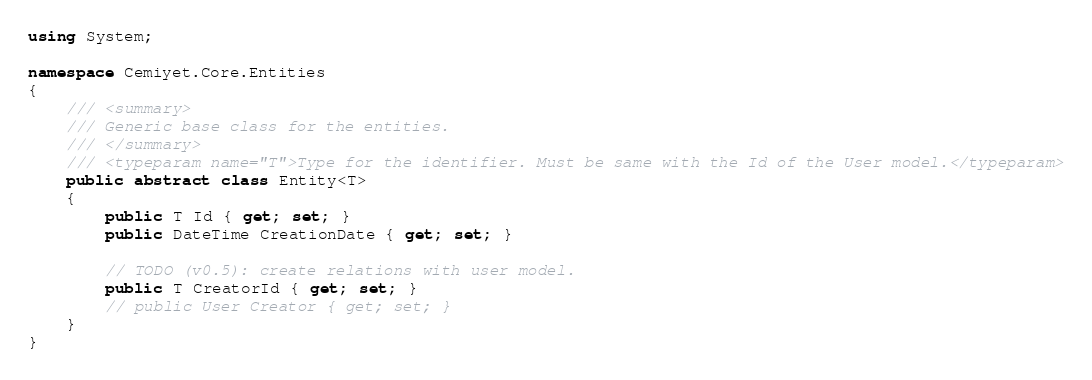<code> <loc_0><loc_0><loc_500><loc_500><_C#_>using System;

namespace Cemiyet.Core.Entities
{
    /// <summary>
    /// Generic base class for the entities.
    /// </summary>
    /// <typeparam name="T">Type for the identifier. Must be same with the Id of the User model.</typeparam>
    public abstract class Entity<T>
    {
        public T Id { get; set; }
        public DateTime CreationDate { get; set; }

        // TODO (v0.5): create relations with user model.
        public T CreatorId { get; set; }
        // public User Creator { get; set; }
    }
}
</code> 